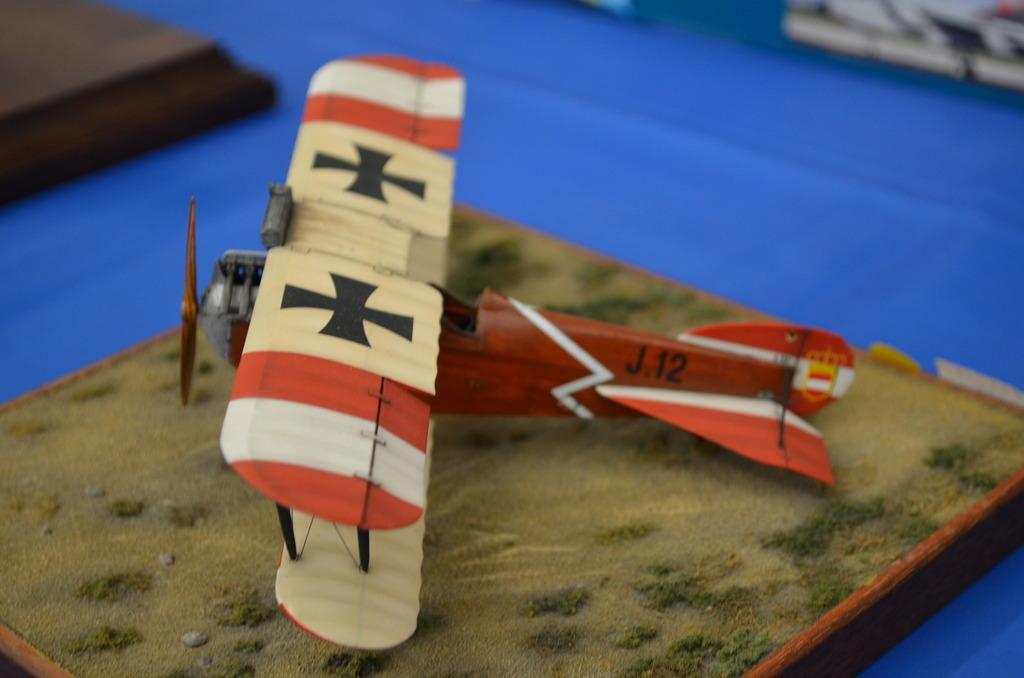What type of toy is featured in the image? There is a toy of a flying jet in the image. Can you describe the background of the image? The background of the image is slightly blurred. What is the tendency of the mine in the image? There is no mine present in the image, so it is not possible to determine any tendency. 